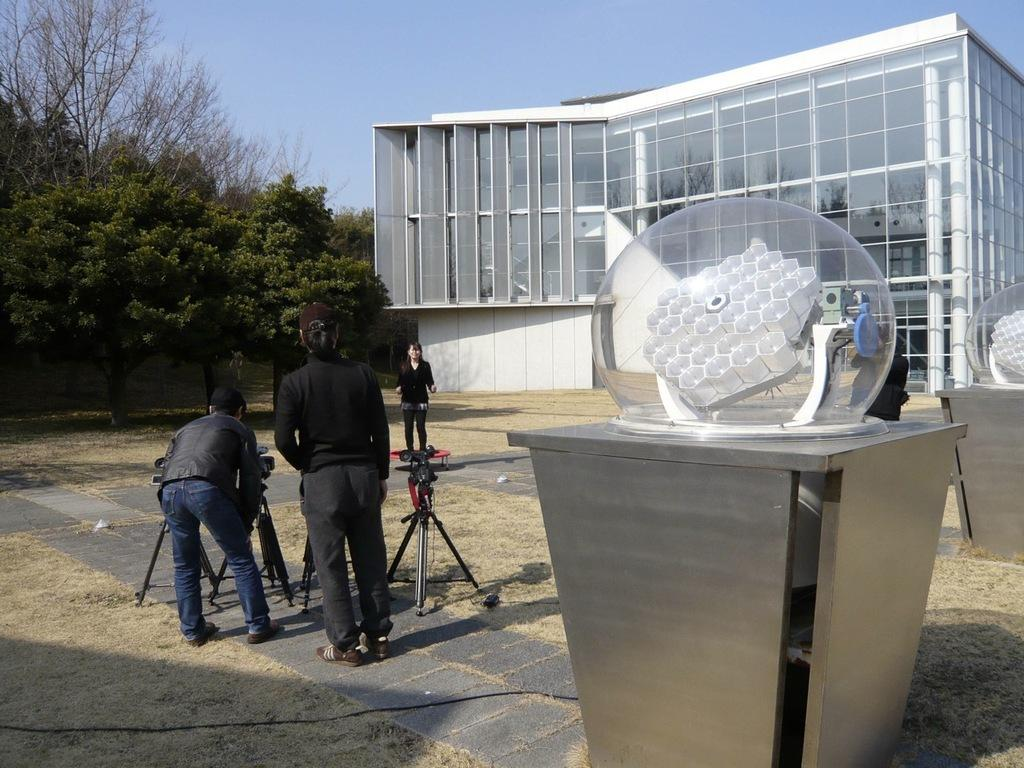How many people are standing in the image? There are three persons standing in the image. What is present between the persons? There are stands between the persons. What can be seen in the background of the image? There is a glass building and trees in the background. What time of day is the maid performing her duties in the image? There is no maid present in the image, and therefore no specific time of day can be determined for her duties. 